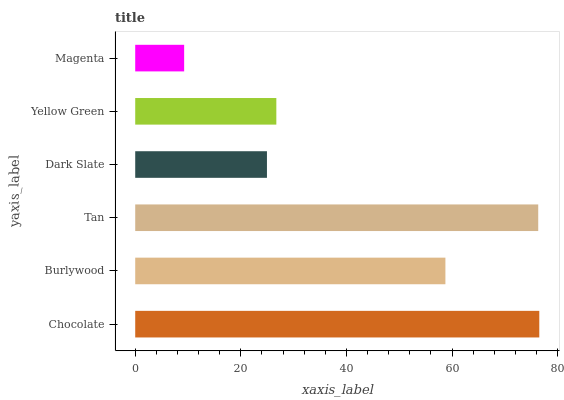Is Magenta the minimum?
Answer yes or no. Yes. Is Chocolate the maximum?
Answer yes or no. Yes. Is Burlywood the minimum?
Answer yes or no. No. Is Burlywood the maximum?
Answer yes or no. No. Is Chocolate greater than Burlywood?
Answer yes or no. Yes. Is Burlywood less than Chocolate?
Answer yes or no. Yes. Is Burlywood greater than Chocolate?
Answer yes or no. No. Is Chocolate less than Burlywood?
Answer yes or no. No. Is Burlywood the high median?
Answer yes or no. Yes. Is Yellow Green the low median?
Answer yes or no. Yes. Is Dark Slate the high median?
Answer yes or no. No. Is Burlywood the low median?
Answer yes or no. No. 